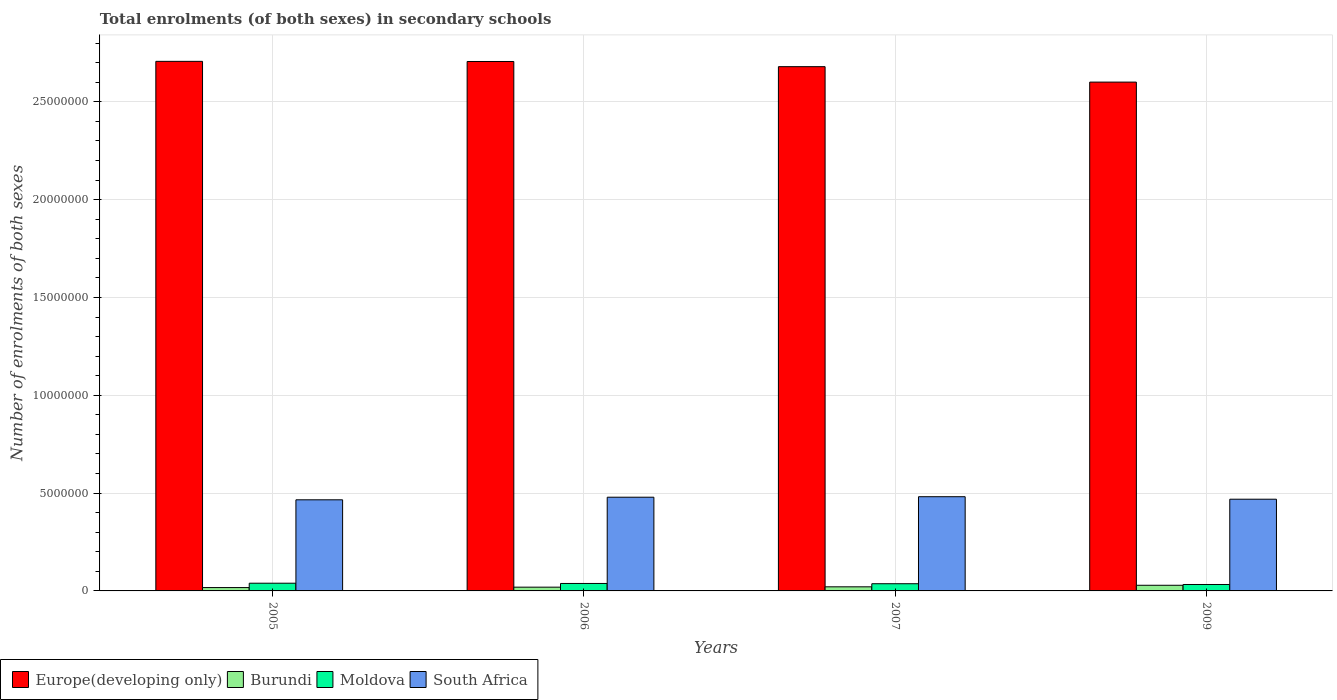Are the number of bars per tick equal to the number of legend labels?
Make the answer very short. Yes. Are the number of bars on each tick of the X-axis equal?
Provide a short and direct response. Yes. What is the label of the 1st group of bars from the left?
Your answer should be very brief. 2005. What is the number of enrolments in secondary schools in South Africa in 2009?
Provide a succinct answer. 4.69e+06. Across all years, what is the maximum number of enrolments in secondary schools in Burundi?
Your answer should be compact. 2.89e+05. Across all years, what is the minimum number of enrolments in secondary schools in South Africa?
Provide a succinct answer. 4.66e+06. In which year was the number of enrolments in secondary schools in South Africa maximum?
Offer a very short reply. 2007. In which year was the number of enrolments in secondary schools in Burundi minimum?
Make the answer very short. 2005. What is the total number of enrolments in secondary schools in Burundi in the graph?
Your answer should be very brief. 8.62e+05. What is the difference between the number of enrolments in secondary schools in South Africa in 2005 and that in 2006?
Keep it short and to the point. -1.33e+05. What is the difference between the number of enrolments in secondary schools in Europe(developing only) in 2005 and the number of enrolments in secondary schools in Burundi in 2006?
Give a very brief answer. 2.69e+07. What is the average number of enrolments in secondary schools in Moldova per year?
Provide a short and direct response. 3.68e+05. In the year 2007, what is the difference between the number of enrolments in secondary schools in South Africa and number of enrolments in secondary schools in Europe(developing only)?
Offer a terse response. -2.20e+07. In how many years, is the number of enrolments in secondary schools in South Africa greater than 7000000?
Your response must be concise. 0. What is the ratio of the number of enrolments in secondary schools in South Africa in 2005 to that in 2009?
Provide a short and direct response. 0.99. Is the difference between the number of enrolments in secondary schools in South Africa in 2006 and 2007 greater than the difference between the number of enrolments in secondary schools in Europe(developing only) in 2006 and 2007?
Provide a succinct answer. No. What is the difference between the highest and the second highest number of enrolments in secondary schools in Europe(developing only)?
Keep it short and to the point. 6902. What is the difference between the highest and the lowest number of enrolments in secondary schools in South Africa?
Your answer should be compact. 1.58e+05. In how many years, is the number of enrolments in secondary schools in Moldova greater than the average number of enrolments in secondary schools in Moldova taken over all years?
Your response must be concise. 2. Is it the case that in every year, the sum of the number of enrolments in secondary schools in Europe(developing only) and number of enrolments in secondary schools in Burundi is greater than the sum of number of enrolments in secondary schools in South Africa and number of enrolments in secondary schools in Moldova?
Provide a succinct answer. No. What does the 2nd bar from the left in 2007 represents?
Your answer should be compact. Burundi. What does the 3rd bar from the right in 2007 represents?
Offer a very short reply. Burundi. Is it the case that in every year, the sum of the number of enrolments in secondary schools in South Africa and number of enrolments in secondary schools in Burundi is greater than the number of enrolments in secondary schools in Europe(developing only)?
Your answer should be very brief. No. Are all the bars in the graph horizontal?
Keep it short and to the point. No. How many years are there in the graph?
Offer a very short reply. 4. What is the difference between two consecutive major ticks on the Y-axis?
Provide a succinct answer. 5.00e+06. Are the values on the major ticks of Y-axis written in scientific E-notation?
Your response must be concise. No. Does the graph contain grids?
Provide a short and direct response. Yes. Where does the legend appear in the graph?
Your answer should be very brief. Bottom left. What is the title of the graph?
Offer a very short reply. Total enrolments (of both sexes) in secondary schools. Does "Cyprus" appear as one of the legend labels in the graph?
Ensure brevity in your answer.  No. What is the label or title of the X-axis?
Provide a short and direct response. Years. What is the label or title of the Y-axis?
Provide a short and direct response. Number of enrolments of both sexes. What is the Number of enrolments of both sexes in Europe(developing only) in 2005?
Provide a short and direct response. 2.71e+07. What is the Number of enrolments of both sexes in Burundi in 2005?
Provide a short and direct response. 1.71e+05. What is the Number of enrolments of both sexes of Moldova in 2005?
Offer a very short reply. 3.94e+05. What is the Number of enrolments of both sexes in South Africa in 2005?
Your answer should be very brief. 4.66e+06. What is the Number of enrolments of both sexes of Europe(developing only) in 2006?
Provide a short and direct response. 2.71e+07. What is the Number of enrolments of both sexes in Burundi in 2006?
Your response must be concise. 1.92e+05. What is the Number of enrolments of both sexes of Moldova in 2006?
Offer a terse response. 3.82e+05. What is the Number of enrolments of both sexes of South Africa in 2006?
Provide a succinct answer. 4.79e+06. What is the Number of enrolments of both sexes of Europe(developing only) in 2007?
Give a very brief answer. 2.68e+07. What is the Number of enrolments of both sexes of Burundi in 2007?
Give a very brief answer. 2.10e+05. What is the Number of enrolments of both sexes of Moldova in 2007?
Provide a short and direct response. 3.68e+05. What is the Number of enrolments of both sexes of South Africa in 2007?
Your answer should be very brief. 4.82e+06. What is the Number of enrolments of both sexes in Europe(developing only) in 2009?
Your answer should be compact. 2.60e+07. What is the Number of enrolments of both sexes of Burundi in 2009?
Keep it short and to the point. 2.89e+05. What is the Number of enrolments of both sexes in Moldova in 2009?
Provide a succinct answer. 3.28e+05. What is the Number of enrolments of both sexes of South Africa in 2009?
Your response must be concise. 4.69e+06. Across all years, what is the maximum Number of enrolments of both sexes of Europe(developing only)?
Your answer should be compact. 2.71e+07. Across all years, what is the maximum Number of enrolments of both sexes in Burundi?
Offer a very short reply. 2.89e+05. Across all years, what is the maximum Number of enrolments of both sexes of Moldova?
Provide a short and direct response. 3.94e+05. Across all years, what is the maximum Number of enrolments of both sexes in South Africa?
Ensure brevity in your answer.  4.82e+06. Across all years, what is the minimum Number of enrolments of both sexes of Europe(developing only)?
Keep it short and to the point. 2.60e+07. Across all years, what is the minimum Number of enrolments of both sexes in Burundi?
Your answer should be very brief. 1.71e+05. Across all years, what is the minimum Number of enrolments of both sexes in Moldova?
Your response must be concise. 3.28e+05. Across all years, what is the minimum Number of enrolments of both sexes in South Africa?
Provide a succinct answer. 4.66e+06. What is the total Number of enrolments of both sexes of Europe(developing only) in the graph?
Ensure brevity in your answer.  1.07e+08. What is the total Number of enrolments of both sexes of Burundi in the graph?
Keep it short and to the point. 8.62e+05. What is the total Number of enrolments of both sexes of Moldova in the graph?
Keep it short and to the point. 1.47e+06. What is the total Number of enrolments of both sexes in South Africa in the graph?
Ensure brevity in your answer.  1.90e+07. What is the difference between the Number of enrolments of both sexes in Europe(developing only) in 2005 and that in 2006?
Provide a short and direct response. 6902. What is the difference between the Number of enrolments of both sexes of Burundi in 2005 and that in 2006?
Give a very brief answer. -2.12e+04. What is the difference between the Number of enrolments of both sexes in Moldova in 2005 and that in 2006?
Your response must be concise. 1.29e+04. What is the difference between the Number of enrolments of both sexes in South Africa in 2005 and that in 2006?
Your answer should be compact. -1.33e+05. What is the difference between the Number of enrolments of both sexes in Europe(developing only) in 2005 and that in 2007?
Ensure brevity in your answer.  2.71e+05. What is the difference between the Number of enrolments of both sexes of Burundi in 2005 and that in 2007?
Provide a short and direct response. -3.88e+04. What is the difference between the Number of enrolments of both sexes in Moldova in 2005 and that in 2007?
Offer a very short reply. 2.68e+04. What is the difference between the Number of enrolments of both sexes in South Africa in 2005 and that in 2007?
Give a very brief answer. -1.58e+05. What is the difference between the Number of enrolments of both sexes in Europe(developing only) in 2005 and that in 2009?
Provide a succinct answer. 1.06e+06. What is the difference between the Number of enrolments of both sexes of Burundi in 2005 and that in 2009?
Offer a very short reply. -1.18e+05. What is the difference between the Number of enrolments of both sexes of Moldova in 2005 and that in 2009?
Make the answer very short. 6.61e+04. What is the difference between the Number of enrolments of both sexes of South Africa in 2005 and that in 2009?
Your response must be concise. -3.03e+04. What is the difference between the Number of enrolments of both sexes of Europe(developing only) in 2006 and that in 2007?
Ensure brevity in your answer.  2.65e+05. What is the difference between the Number of enrolments of both sexes in Burundi in 2006 and that in 2007?
Your response must be concise. -1.76e+04. What is the difference between the Number of enrolments of both sexes of Moldova in 2006 and that in 2007?
Your answer should be compact. 1.39e+04. What is the difference between the Number of enrolments of both sexes in South Africa in 2006 and that in 2007?
Give a very brief answer. -2.56e+04. What is the difference between the Number of enrolments of both sexes of Europe(developing only) in 2006 and that in 2009?
Your response must be concise. 1.05e+06. What is the difference between the Number of enrolments of both sexes of Burundi in 2006 and that in 2009?
Provide a short and direct response. -9.67e+04. What is the difference between the Number of enrolments of both sexes of Moldova in 2006 and that in 2009?
Your answer should be very brief. 5.31e+04. What is the difference between the Number of enrolments of both sexes of South Africa in 2006 and that in 2009?
Give a very brief answer. 1.02e+05. What is the difference between the Number of enrolments of both sexes in Europe(developing only) in 2007 and that in 2009?
Give a very brief answer. 7.89e+05. What is the difference between the Number of enrolments of both sexes in Burundi in 2007 and that in 2009?
Your response must be concise. -7.90e+04. What is the difference between the Number of enrolments of both sexes of Moldova in 2007 and that in 2009?
Give a very brief answer. 3.92e+04. What is the difference between the Number of enrolments of both sexes of South Africa in 2007 and that in 2009?
Keep it short and to the point. 1.28e+05. What is the difference between the Number of enrolments of both sexes in Europe(developing only) in 2005 and the Number of enrolments of both sexes in Burundi in 2006?
Your answer should be very brief. 2.69e+07. What is the difference between the Number of enrolments of both sexes of Europe(developing only) in 2005 and the Number of enrolments of both sexes of Moldova in 2006?
Keep it short and to the point. 2.67e+07. What is the difference between the Number of enrolments of both sexes of Europe(developing only) in 2005 and the Number of enrolments of both sexes of South Africa in 2006?
Provide a succinct answer. 2.23e+07. What is the difference between the Number of enrolments of both sexes of Burundi in 2005 and the Number of enrolments of both sexes of Moldova in 2006?
Make the answer very short. -2.10e+05. What is the difference between the Number of enrolments of both sexes in Burundi in 2005 and the Number of enrolments of both sexes in South Africa in 2006?
Your response must be concise. -4.62e+06. What is the difference between the Number of enrolments of both sexes of Moldova in 2005 and the Number of enrolments of both sexes of South Africa in 2006?
Your response must be concise. -4.40e+06. What is the difference between the Number of enrolments of both sexes of Europe(developing only) in 2005 and the Number of enrolments of both sexes of Burundi in 2007?
Your answer should be compact. 2.69e+07. What is the difference between the Number of enrolments of both sexes of Europe(developing only) in 2005 and the Number of enrolments of both sexes of Moldova in 2007?
Your answer should be compact. 2.67e+07. What is the difference between the Number of enrolments of both sexes in Europe(developing only) in 2005 and the Number of enrolments of both sexes in South Africa in 2007?
Your response must be concise. 2.23e+07. What is the difference between the Number of enrolments of both sexes of Burundi in 2005 and the Number of enrolments of both sexes of Moldova in 2007?
Your answer should be very brief. -1.97e+05. What is the difference between the Number of enrolments of both sexes of Burundi in 2005 and the Number of enrolments of both sexes of South Africa in 2007?
Provide a short and direct response. -4.64e+06. What is the difference between the Number of enrolments of both sexes in Moldova in 2005 and the Number of enrolments of both sexes in South Africa in 2007?
Make the answer very short. -4.42e+06. What is the difference between the Number of enrolments of both sexes in Europe(developing only) in 2005 and the Number of enrolments of both sexes in Burundi in 2009?
Ensure brevity in your answer.  2.68e+07. What is the difference between the Number of enrolments of both sexes in Europe(developing only) in 2005 and the Number of enrolments of both sexes in Moldova in 2009?
Provide a succinct answer. 2.67e+07. What is the difference between the Number of enrolments of both sexes of Europe(developing only) in 2005 and the Number of enrolments of both sexes of South Africa in 2009?
Your response must be concise. 2.24e+07. What is the difference between the Number of enrolments of both sexes of Burundi in 2005 and the Number of enrolments of both sexes of Moldova in 2009?
Your response must be concise. -1.57e+05. What is the difference between the Number of enrolments of both sexes of Burundi in 2005 and the Number of enrolments of both sexes of South Africa in 2009?
Provide a succinct answer. -4.52e+06. What is the difference between the Number of enrolments of both sexes in Moldova in 2005 and the Number of enrolments of both sexes in South Africa in 2009?
Provide a short and direct response. -4.29e+06. What is the difference between the Number of enrolments of both sexes in Europe(developing only) in 2006 and the Number of enrolments of both sexes in Burundi in 2007?
Offer a terse response. 2.69e+07. What is the difference between the Number of enrolments of both sexes in Europe(developing only) in 2006 and the Number of enrolments of both sexes in Moldova in 2007?
Provide a succinct answer. 2.67e+07. What is the difference between the Number of enrolments of both sexes in Europe(developing only) in 2006 and the Number of enrolments of both sexes in South Africa in 2007?
Provide a succinct answer. 2.22e+07. What is the difference between the Number of enrolments of both sexes in Burundi in 2006 and the Number of enrolments of both sexes in Moldova in 2007?
Give a very brief answer. -1.75e+05. What is the difference between the Number of enrolments of both sexes in Burundi in 2006 and the Number of enrolments of both sexes in South Africa in 2007?
Give a very brief answer. -4.62e+06. What is the difference between the Number of enrolments of both sexes of Moldova in 2006 and the Number of enrolments of both sexes of South Africa in 2007?
Provide a short and direct response. -4.43e+06. What is the difference between the Number of enrolments of both sexes of Europe(developing only) in 2006 and the Number of enrolments of both sexes of Burundi in 2009?
Your answer should be compact. 2.68e+07. What is the difference between the Number of enrolments of both sexes of Europe(developing only) in 2006 and the Number of enrolments of both sexes of Moldova in 2009?
Your answer should be compact. 2.67e+07. What is the difference between the Number of enrolments of both sexes in Europe(developing only) in 2006 and the Number of enrolments of both sexes in South Africa in 2009?
Provide a succinct answer. 2.24e+07. What is the difference between the Number of enrolments of both sexes in Burundi in 2006 and the Number of enrolments of both sexes in Moldova in 2009?
Make the answer very short. -1.36e+05. What is the difference between the Number of enrolments of both sexes in Burundi in 2006 and the Number of enrolments of both sexes in South Africa in 2009?
Your answer should be compact. -4.50e+06. What is the difference between the Number of enrolments of both sexes in Moldova in 2006 and the Number of enrolments of both sexes in South Africa in 2009?
Make the answer very short. -4.31e+06. What is the difference between the Number of enrolments of both sexes in Europe(developing only) in 2007 and the Number of enrolments of both sexes in Burundi in 2009?
Provide a succinct answer. 2.65e+07. What is the difference between the Number of enrolments of both sexes of Europe(developing only) in 2007 and the Number of enrolments of both sexes of Moldova in 2009?
Your answer should be compact. 2.65e+07. What is the difference between the Number of enrolments of both sexes in Europe(developing only) in 2007 and the Number of enrolments of both sexes in South Africa in 2009?
Your answer should be very brief. 2.21e+07. What is the difference between the Number of enrolments of both sexes in Burundi in 2007 and the Number of enrolments of both sexes in Moldova in 2009?
Offer a terse response. -1.18e+05. What is the difference between the Number of enrolments of both sexes of Burundi in 2007 and the Number of enrolments of both sexes of South Africa in 2009?
Offer a terse response. -4.48e+06. What is the difference between the Number of enrolments of both sexes in Moldova in 2007 and the Number of enrolments of both sexes in South Africa in 2009?
Offer a very short reply. -4.32e+06. What is the average Number of enrolments of both sexes in Europe(developing only) per year?
Give a very brief answer. 2.67e+07. What is the average Number of enrolments of both sexes in Burundi per year?
Provide a succinct answer. 2.16e+05. What is the average Number of enrolments of both sexes of Moldova per year?
Provide a short and direct response. 3.68e+05. What is the average Number of enrolments of both sexes in South Africa per year?
Give a very brief answer. 4.74e+06. In the year 2005, what is the difference between the Number of enrolments of both sexes of Europe(developing only) and Number of enrolments of both sexes of Burundi?
Provide a succinct answer. 2.69e+07. In the year 2005, what is the difference between the Number of enrolments of both sexes of Europe(developing only) and Number of enrolments of both sexes of Moldova?
Provide a succinct answer. 2.67e+07. In the year 2005, what is the difference between the Number of enrolments of both sexes in Europe(developing only) and Number of enrolments of both sexes in South Africa?
Your answer should be very brief. 2.24e+07. In the year 2005, what is the difference between the Number of enrolments of both sexes of Burundi and Number of enrolments of both sexes of Moldova?
Keep it short and to the point. -2.23e+05. In the year 2005, what is the difference between the Number of enrolments of both sexes of Burundi and Number of enrolments of both sexes of South Africa?
Make the answer very short. -4.49e+06. In the year 2005, what is the difference between the Number of enrolments of both sexes in Moldova and Number of enrolments of both sexes in South Africa?
Your answer should be very brief. -4.26e+06. In the year 2006, what is the difference between the Number of enrolments of both sexes of Europe(developing only) and Number of enrolments of both sexes of Burundi?
Your answer should be very brief. 2.69e+07. In the year 2006, what is the difference between the Number of enrolments of both sexes of Europe(developing only) and Number of enrolments of both sexes of Moldova?
Provide a succinct answer. 2.67e+07. In the year 2006, what is the difference between the Number of enrolments of both sexes of Europe(developing only) and Number of enrolments of both sexes of South Africa?
Provide a short and direct response. 2.23e+07. In the year 2006, what is the difference between the Number of enrolments of both sexes in Burundi and Number of enrolments of both sexes in Moldova?
Keep it short and to the point. -1.89e+05. In the year 2006, what is the difference between the Number of enrolments of both sexes of Burundi and Number of enrolments of both sexes of South Africa?
Provide a succinct answer. -4.60e+06. In the year 2006, what is the difference between the Number of enrolments of both sexes of Moldova and Number of enrolments of both sexes of South Africa?
Give a very brief answer. -4.41e+06. In the year 2007, what is the difference between the Number of enrolments of both sexes of Europe(developing only) and Number of enrolments of both sexes of Burundi?
Your answer should be very brief. 2.66e+07. In the year 2007, what is the difference between the Number of enrolments of both sexes of Europe(developing only) and Number of enrolments of both sexes of Moldova?
Offer a very short reply. 2.64e+07. In the year 2007, what is the difference between the Number of enrolments of both sexes in Europe(developing only) and Number of enrolments of both sexes in South Africa?
Ensure brevity in your answer.  2.20e+07. In the year 2007, what is the difference between the Number of enrolments of both sexes of Burundi and Number of enrolments of both sexes of Moldova?
Provide a succinct answer. -1.58e+05. In the year 2007, what is the difference between the Number of enrolments of both sexes of Burundi and Number of enrolments of both sexes of South Africa?
Your answer should be very brief. -4.61e+06. In the year 2007, what is the difference between the Number of enrolments of both sexes of Moldova and Number of enrolments of both sexes of South Africa?
Ensure brevity in your answer.  -4.45e+06. In the year 2009, what is the difference between the Number of enrolments of both sexes of Europe(developing only) and Number of enrolments of both sexes of Burundi?
Your answer should be compact. 2.57e+07. In the year 2009, what is the difference between the Number of enrolments of both sexes in Europe(developing only) and Number of enrolments of both sexes in Moldova?
Give a very brief answer. 2.57e+07. In the year 2009, what is the difference between the Number of enrolments of both sexes in Europe(developing only) and Number of enrolments of both sexes in South Africa?
Offer a very short reply. 2.13e+07. In the year 2009, what is the difference between the Number of enrolments of both sexes in Burundi and Number of enrolments of both sexes in Moldova?
Your answer should be compact. -3.95e+04. In the year 2009, what is the difference between the Number of enrolments of both sexes of Burundi and Number of enrolments of both sexes of South Africa?
Ensure brevity in your answer.  -4.40e+06. In the year 2009, what is the difference between the Number of enrolments of both sexes of Moldova and Number of enrolments of both sexes of South Africa?
Give a very brief answer. -4.36e+06. What is the ratio of the Number of enrolments of both sexes of Europe(developing only) in 2005 to that in 2006?
Offer a very short reply. 1. What is the ratio of the Number of enrolments of both sexes of Burundi in 2005 to that in 2006?
Ensure brevity in your answer.  0.89. What is the ratio of the Number of enrolments of both sexes of Moldova in 2005 to that in 2006?
Provide a succinct answer. 1.03. What is the ratio of the Number of enrolments of both sexes in South Africa in 2005 to that in 2006?
Your answer should be compact. 0.97. What is the ratio of the Number of enrolments of both sexes in Burundi in 2005 to that in 2007?
Offer a terse response. 0.81. What is the ratio of the Number of enrolments of both sexes of Moldova in 2005 to that in 2007?
Give a very brief answer. 1.07. What is the ratio of the Number of enrolments of both sexes in South Africa in 2005 to that in 2007?
Offer a very short reply. 0.97. What is the ratio of the Number of enrolments of both sexes in Europe(developing only) in 2005 to that in 2009?
Provide a short and direct response. 1.04. What is the ratio of the Number of enrolments of both sexes of Burundi in 2005 to that in 2009?
Give a very brief answer. 0.59. What is the ratio of the Number of enrolments of both sexes in Moldova in 2005 to that in 2009?
Ensure brevity in your answer.  1.2. What is the ratio of the Number of enrolments of both sexes of South Africa in 2005 to that in 2009?
Offer a terse response. 0.99. What is the ratio of the Number of enrolments of both sexes of Europe(developing only) in 2006 to that in 2007?
Offer a very short reply. 1.01. What is the ratio of the Number of enrolments of both sexes in Burundi in 2006 to that in 2007?
Offer a very short reply. 0.92. What is the ratio of the Number of enrolments of both sexes of Moldova in 2006 to that in 2007?
Provide a short and direct response. 1.04. What is the ratio of the Number of enrolments of both sexes in South Africa in 2006 to that in 2007?
Provide a short and direct response. 0.99. What is the ratio of the Number of enrolments of both sexes in Europe(developing only) in 2006 to that in 2009?
Your answer should be compact. 1.04. What is the ratio of the Number of enrolments of both sexes of Burundi in 2006 to that in 2009?
Make the answer very short. 0.67. What is the ratio of the Number of enrolments of both sexes in Moldova in 2006 to that in 2009?
Ensure brevity in your answer.  1.16. What is the ratio of the Number of enrolments of both sexes of South Africa in 2006 to that in 2009?
Your answer should be compact. 1.02. What is the ratio of the Number of enrolments of both sexes of Europe(developing only) in 2007 to that in 2009?
Give a very brief answer. 1.03. What is the ratio of the Number of enrolments of both sexes of Burundi in 2007 to that in 2009?
Your answer should be compact. 0.73. What is the ratio of the Number of enrolments of both sexes in Moldova in 2007 to that in 2009?
Provide a short and direct response. 1.12. What is the ratio of the Number of enrolments of both sexes in South Africa in 2007 to that in 2009?
Your response must be concise. 1.03. What is the difference between the highest and the second highest Number of enrolments of both sexes of Europe(developing only)?
Offer a terse response. 6902. What is the difference between the highest and the second highest Number of enrolments of both sexes in Burundi?
Give a very brief answer. 7.90e+04. What is the difference between the highest and the second highest Number of enrolments of both sexes in Moldova?
Your answer should be very brief. 1.29e+04. What is the difference between the highest and the second highest Number of enrolments of both sexes in South Africa?
Give a very brief answer. 2.56e+04. What is the difference between the highest and the lowest Number of enrolments of both sexes of Europe(developing only)?
Your response must be concise. 1.06e+06. What is the difference between the highest and the lowest Number of enrolments of both sexes of Burundi?
Provide a succinct answer. 1.18e+05. What is the difference between the highest and the lowest Number of enrolments of both sexes of Moldova?
Provide a short and direct response. 6.61e+04. What is the difference between the highest and the lowest Number of enrolments of both sexes in South Africa?
Give a very brief answer. 1.58e+05. 